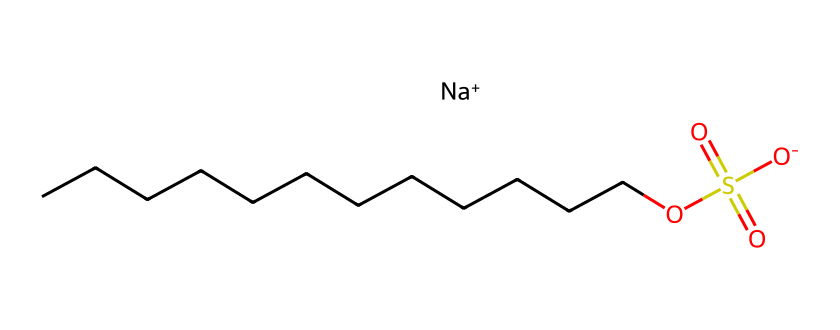What is the main functional group in this chemical? The chemical structure contains the sulfonate group (-SO3^-), which is a key functional group found in detergents, signifying its ability to interact with water and oils.
Answer: sulfonate How many carbon atoms are in the long hydrocarbon chain? By examining the chain 'CCCCCCCCCCCC', we can count the carbon atoms easily; there are twelve 'C's visible in the chain.
Answer: twelve What ionic component is present in this detergent? The presence of 'Na+' indicates that sodium is the ionic component in the structure, which is typical for sodium-based detergents, enhancing solubility in water.
Answer: sodium What role does the sulfonate group play in this detergent? The sulfonate group enhances the detergent's ability to lower surface tension, making it effective at emulsifying oils and dirt, promoting cleaning.
Answer: emulsifying What type of chemical is this compound classified as? This compound is classified as an anionic surfactant due to the presence of a negatively charged sulfonate group and its ability to act as a detergent.
Answer: anionic surfactant How many oxygen atoms are present in the sulfonate group? In the sulfonate group, there are three oxygen atoms (noted as 'O' and '(=O)' in the SMILES), which are integral to the functional nature of the sulfonate.
Answer: three 